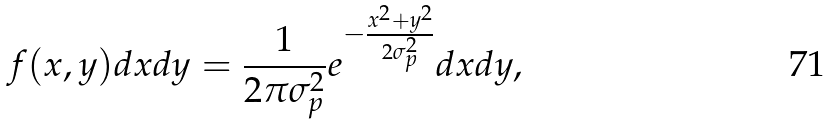Convert formula to latex. <formula><loc_0><loc_0><loc_500><loc_500>f ( x , y ) d x d y = \frac { 1 } { 2 \pi \sigma _ { p } ^ { 2 } } e ^ { - \frac { x ^ { 2 } + y ^ { 2 } } { 2 \sigma _ { p } ^ { 2 } } } d x d y ,</formula> 